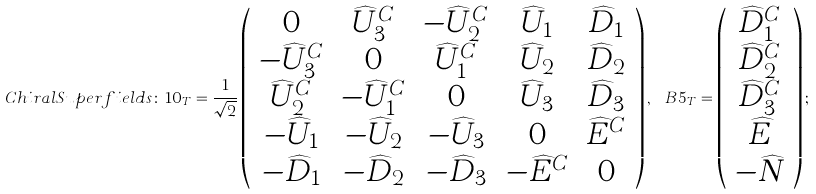<formula> <loc_0><loc_0><loc_500><loc_500>C h i r a l S u p e r f i e l d s \colon \, { 1 0 _ { T } } = \frac { 1 } { \sqrt { 2 } } \left ( \begin{array} { c c c c c } 0 & \widehat { U } _ { 3 } ^ { C } & - \widehat { U } _ { 2 } ^ { C } & \widehat { U } _ { 1 } & \widehat { D } _ { 1 } \\ - \widehat { U } _ { 3 } ^ { C } & 0 & \widehat { U } _ { 1 } ^ { C } & \widehat { U } _ { 2 } & \widehat { D } _ { 2 } \\ \widehat { U } _ { 2 } ^ { C } & - \widehat { U } _ { 1 } ^ { C } & 0 & \widehat { U } _ { 3 } & \widehat { D } _ { 3 } \\ - \widehat { U } _ { 1 } & - \widehat { U } _ { 2 } & - \widehat { U } _ { 3 } & 0 & \widehat { E } ^ { C } \\ - \widehat { D } _ { 1 } & - \widehat { D } _ { 2 } & - \widehat { D } _ { 3 } & - \widehat { E } ^ { C } & 0 \\ \end{array} \right ) , \, { \ B 5 _ { T } } = \left ( \begin{array} { c } \widehat { D } _ { 1 } ^ { C } \\ \widehat { D } _ { 2 } ^ { C } \\ \widehat { D } _ { 3 } ^ { C } \\ \widehat { E } \\ - \widehat { N } \\ \end{array} \right ) ;</formula> 